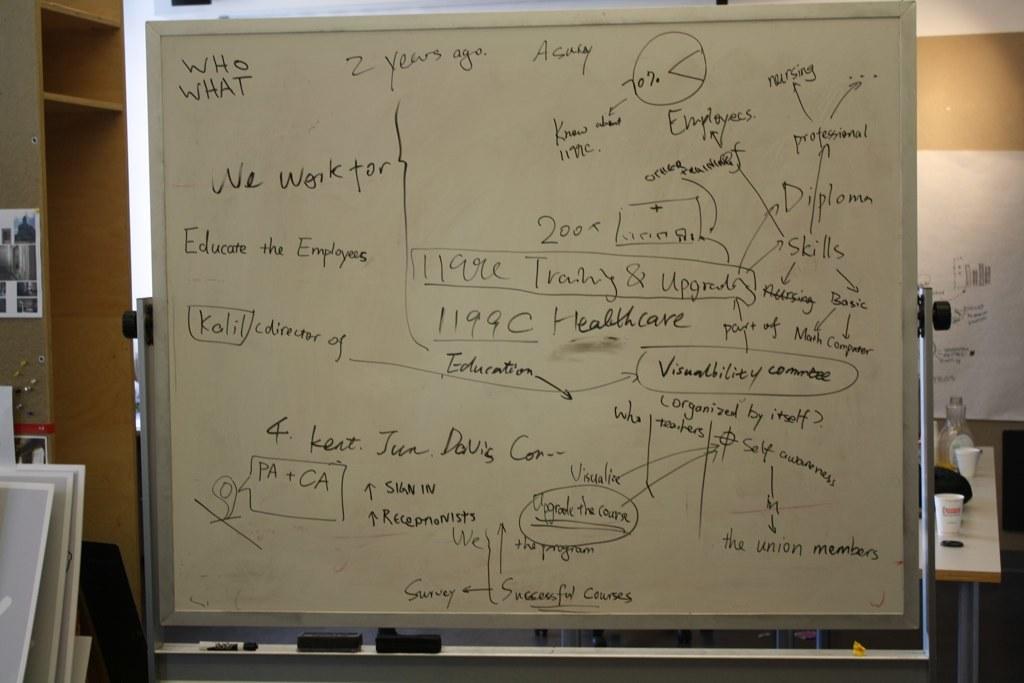How many years ago was it?
Offer a terse response. 2. 